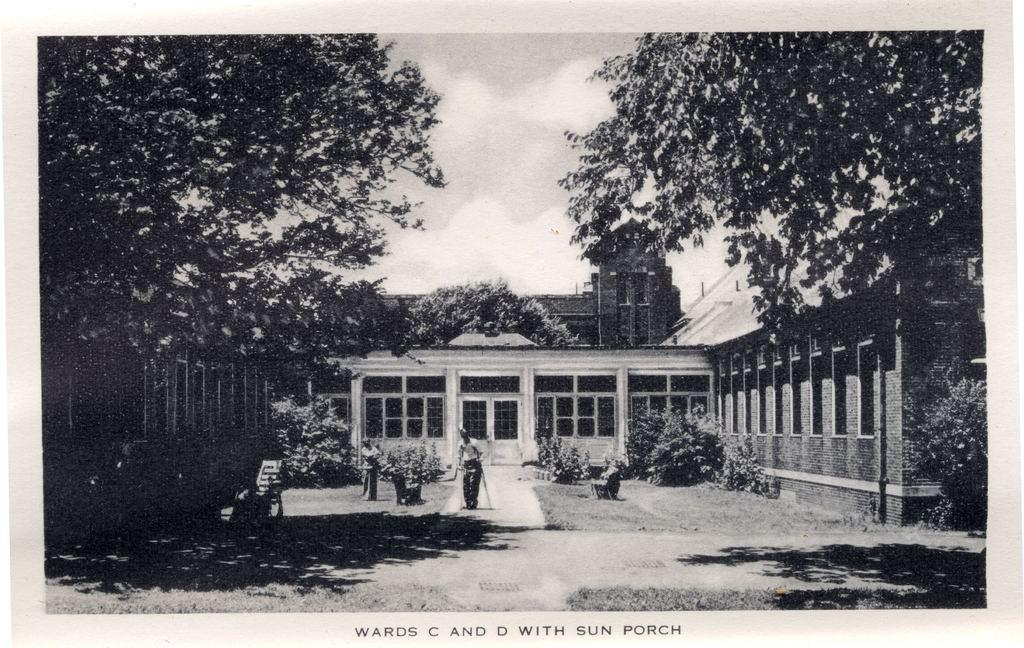Provide a one-sentence caption for the provided image. Wards C and D with sun porch picture that is black and white. 